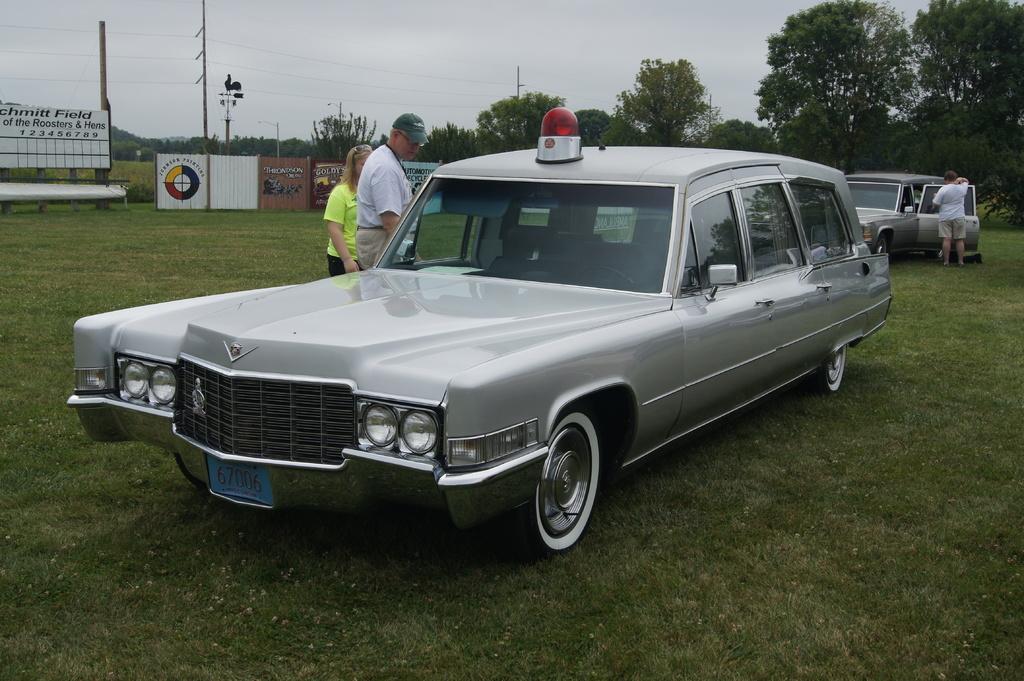In one or two sentences, can you explain what this image depicts? In this picture there is a man who is wearing t-shirt and trouser. Besides him there is a woman who is wearing green t-shirt and black trouser. Both of them are standing near to the car. On the right there is another man who is standing near to the door of the car. in the background I can see the banners, posters, poles, trees, plants, fencing and the steel partition. At the top I can see the sky and clouds. At the bottom I can see the grass. 